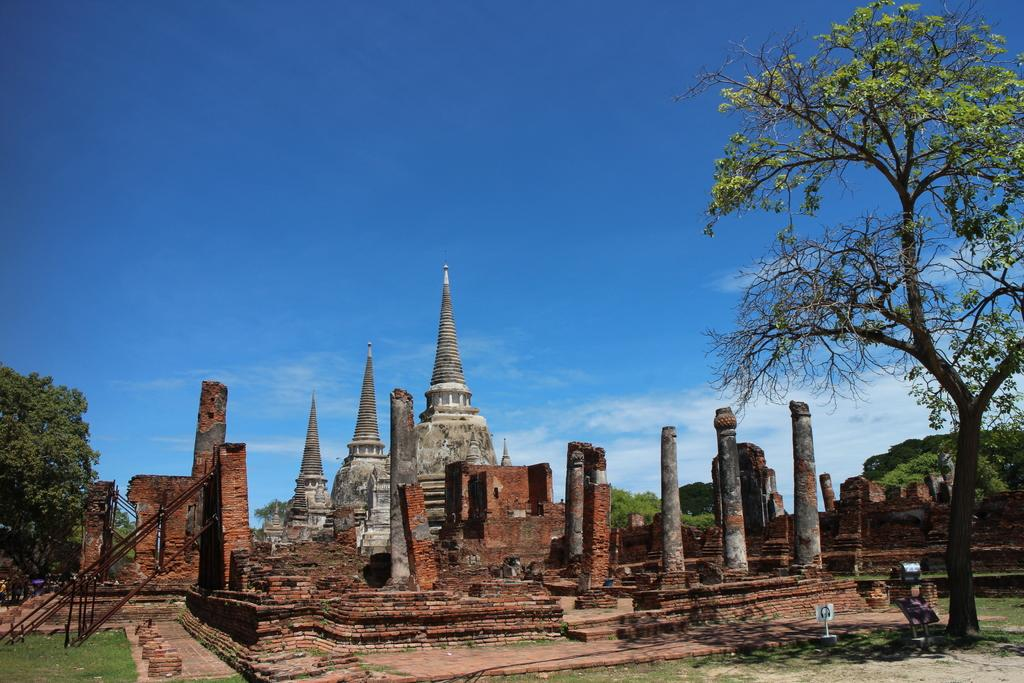What type of structure can be seen in the image? There are ruins in the image. What architectural features can be observed in the ruins? The ruins have pillars and a brick wall. What object is present in the image that might be used for climbing or reaching higher areas? There is a ladder in the image. What type of vegetation is present on the sides of the image? Trees are present on the sides of the image. What can be seen in the background of the image? The sky is visible in the background of the image, and clouds are present in the sky. How much wealth is stored in the bottle in the image? There is no bottle present in the image, and therefore no wealth can be stored in it. What type of rail is used to transport the ruins in the image? There is no rail present in the image, and the ruins are not being transported. 